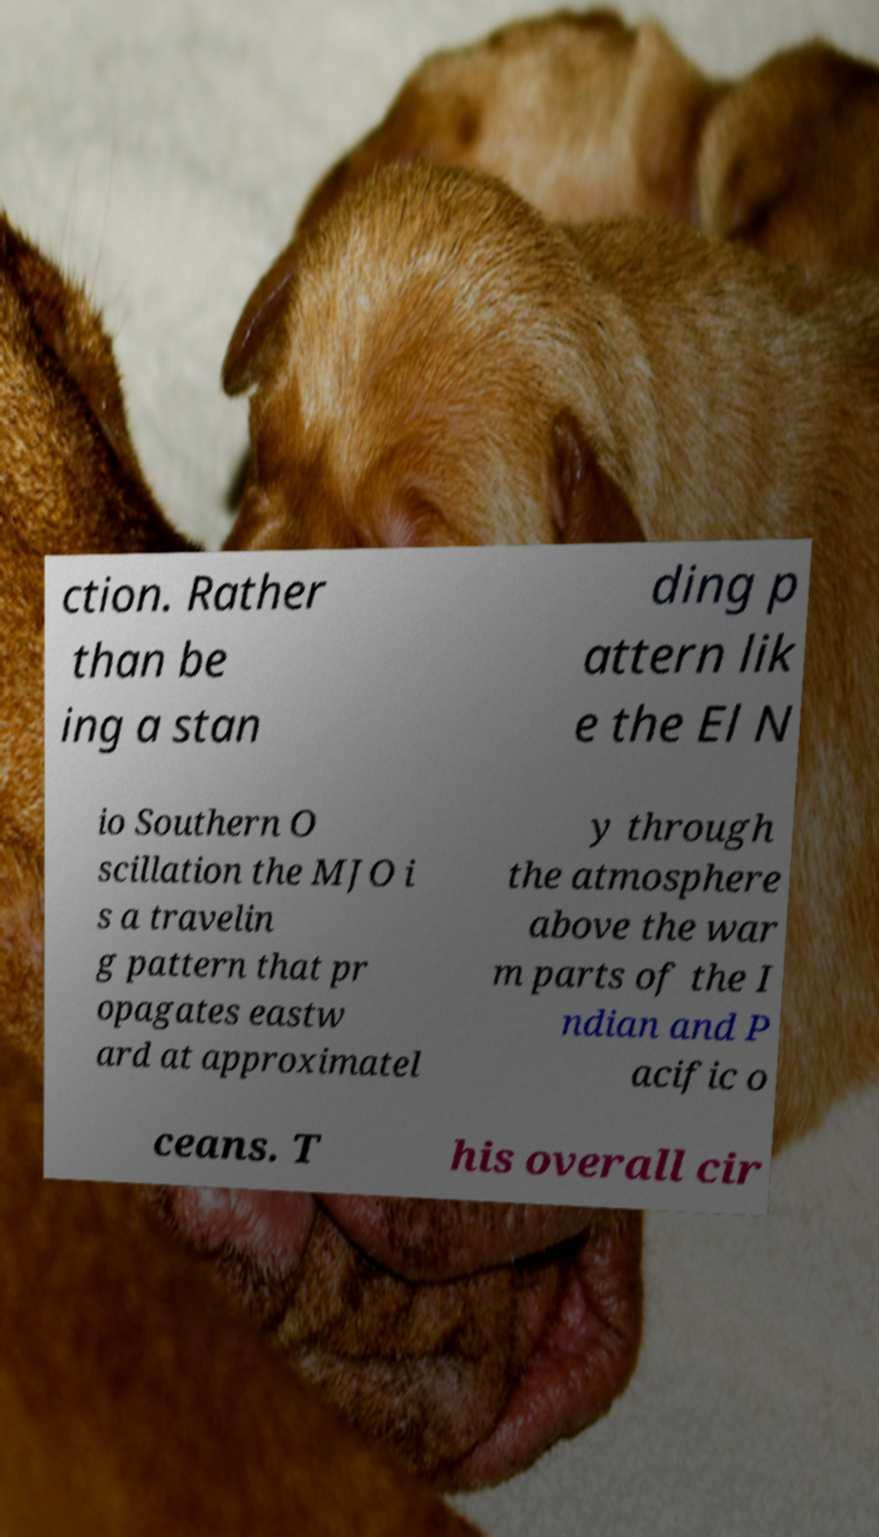Please identify and transcribe the text found in this image. ction. Rather than be ing a stan ding p attern lik e the El N io Southern O scillation the MJO i s a travelin g pattern that pr opagates eastw ard at approximatel y through the atmosphere above the war m parts of the I ndian and P acific o ceans. T his overall cir 